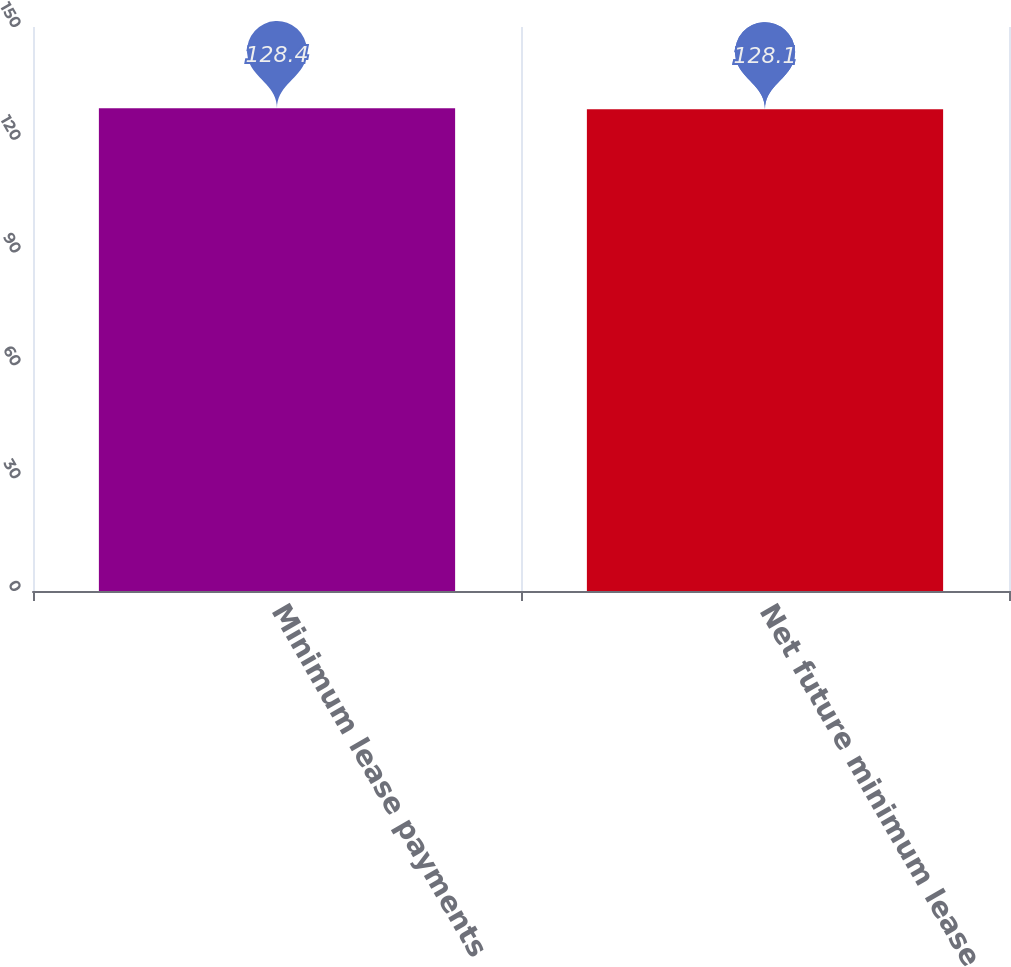Convert chart. <chart><loc_0><loc_0><loc_500><loc_500><bar_chart><fcel>Minimum lease payments<fcel>Net future minimum lease<nl><fcel>128.4<fcel>128.1<nl></chart> 